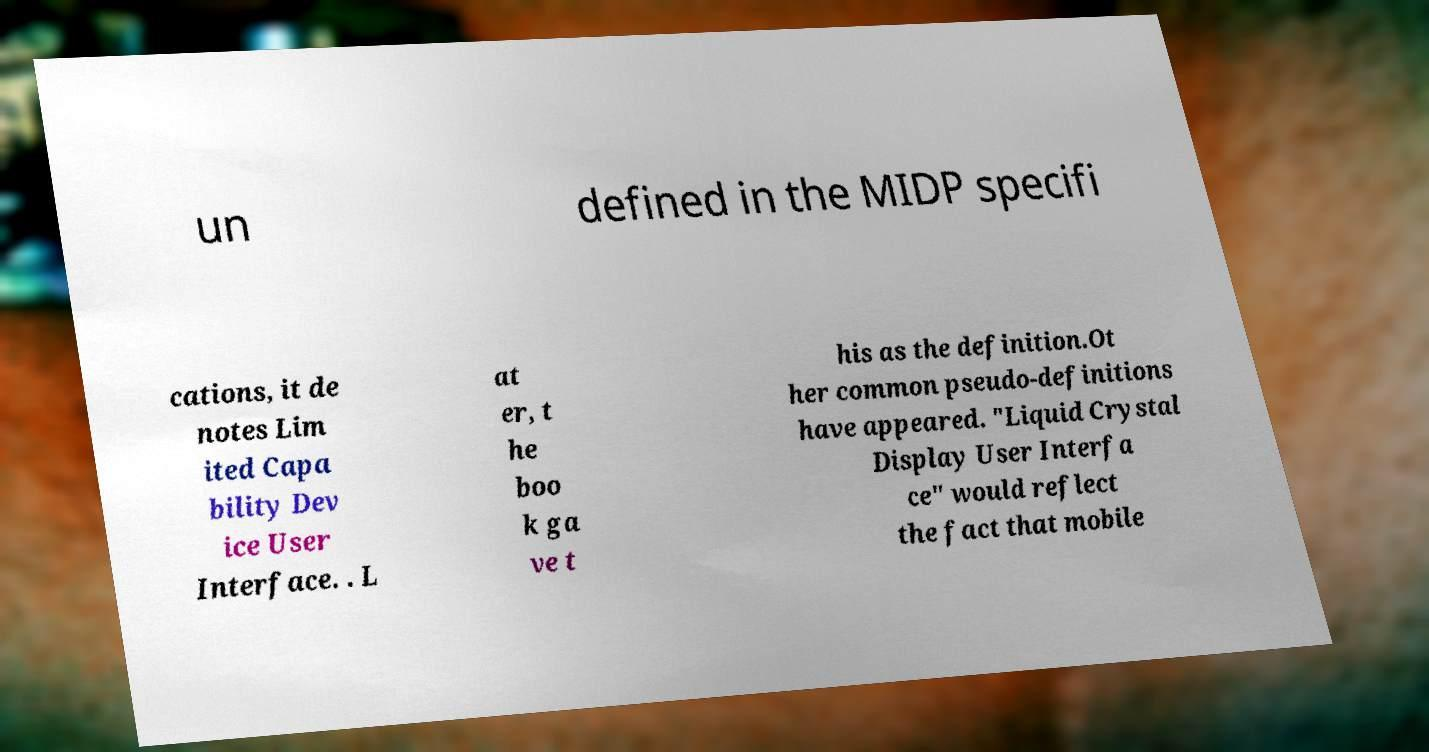There's text embedded in this image that I need extracted. Can you transcribe it verbatim? un defined in the MIDP specifi cations, it de notes Lim ited Capa bility Dev ice User Interface. . L at er, t he boo k ga ve t his as the definition.Ot her common pseudo-definitions have appeared. "Liquid Crystal Display User Interfa ce" would reflect the fact that mobile 